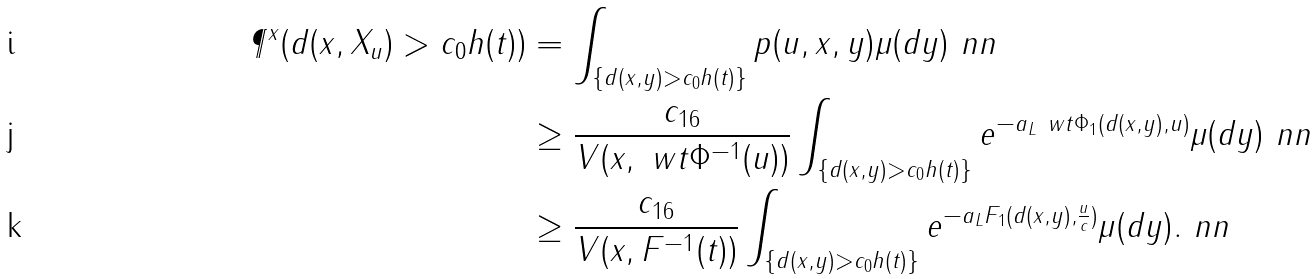<formula> <loc_0><loc_0><loc_500><loc_500>\P ^ { x } ( d ( x , X _ { u } ) > c _ { 0 } h ( t ) ) & = \int _ { \{ d ( x , y ) > c _ { 0 } h ( t ) \} } p ( u , x , y ) \mu ( d y ) \ n n \\ & \geq \frac { c _ { 1 6 } } { V ( x , \ w t \Phi ^ { - 1 } ( u ) ) } \int _ { \{ d ( x , y ) > c _ { 0 } h ( t ) \} } e ^ { - a _ { L } \ w t \Phi _ { 1 } ( d ( x , y ) , u ) } \mu ( d y ) \ n n \\ & \geq \frac { c _ { 1 6 } } { V ( x , F ^ { - 1 } ( t ) ) } \int _ { \{ d ( x , y ) > c _ { 0 } h ( t ) \} } e ^ { - a _ { L } F _ { 1 } ( d ( x , y ) , \frac { u } { c } ) } \mu ( d y ) . \ n n</formula> 